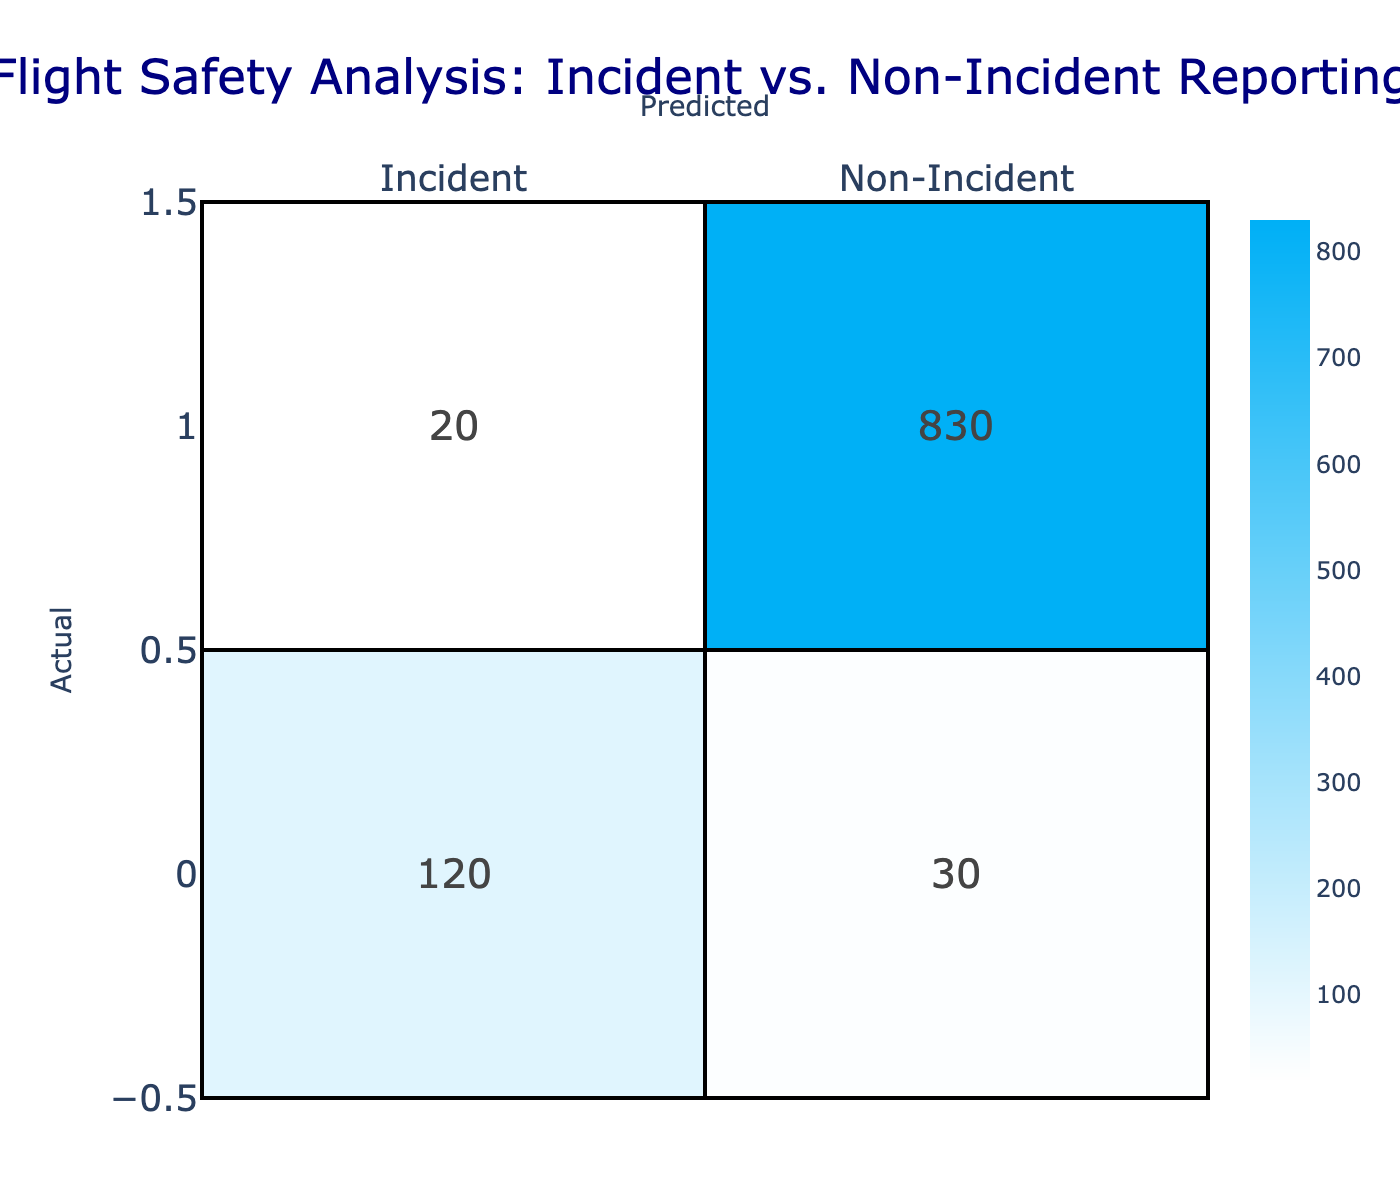What is the total number of incidents reported? The number of incidents can be found in the "Incident" row under the "Actual" column. The value is 120. Therefore, the total number of reported incidents is 120.
Answer: 120 How many non-incidents were correctly identified? The correctly identified non-incidents are found at the intersection of the "Non-Incident" row and "Non-Incident" column. The value here is 830. This indicates that these cases were accurately predicted as non-incidents.
Answer: 830 What is the total number of cases predicted as incidents? To find this, we look at the entire "Incident" column, which contains the values 120 (true positives) and 30 (false positives). Summing these gives us 120 + 30 = 150. This represents all cases predicted as incidents.
Answer: 150 What percentage of actual incidents were correctly predicted? To calculate the percentage of correctly predicted incidents, divide the number of correctly predicted incidents (120) by the total number of actual incidents, which is the sum of true positives (120) and false negatives (20). The total actual incidents = 120 + 20 = 140. Thus, the percentage is (120 / 140) * 100 = 85.71%.
Answer: 85.71% Is the number of false positives greater than the number of false negatives? False positives are the cases predicted as incidents that are actually non-incidents, which is 30. False negatives are the cases predicted as non-incidents but are actually incidents, which is 20. Since 30 > 20, the statement is true.
Answer: Yes What is the total number of non-incidents reported? To find the total number of non-incidents, we can check the "Non-Incident" row under the "Actual" column. The value is found by adding actual non-incidents, which is 830 (correctly predicted) and 20 (wrongly predicted). Thus, the total = 830 + 20 = 850.
Answer: 850 How many total incidents were misclassified as non-incidents? Misclassified incidents can be found in the "Non-Incident" row under the "Incident" column. The value of misclassified incidents is 20. Thus, the total incidents misclassified as non-incidents is 20.
Answer: 20 What is the sum of incidents and non-incidents that were correctly reported? The sum of correctly reported incidents (120) and correctly reported non-incidents (830) is required. Adding these gives 120 + 830 = 950. So, the combined total of correctly reported incidents and non-incidents is 950.
Answer: 950 If we combine both incidents and non-incidents predicted, what is the accuracy? The total predictions can be calculated by adding all values in the table: 120 + 30 + 20 + 830 = 1000. The accuracy can be calculated by taking the sum of correctly classified cases (120 + 830 = 950) and dividing it by the total cases. Accuracy = (950 / 1000) * 100 = 95%.
Answer: 95% 